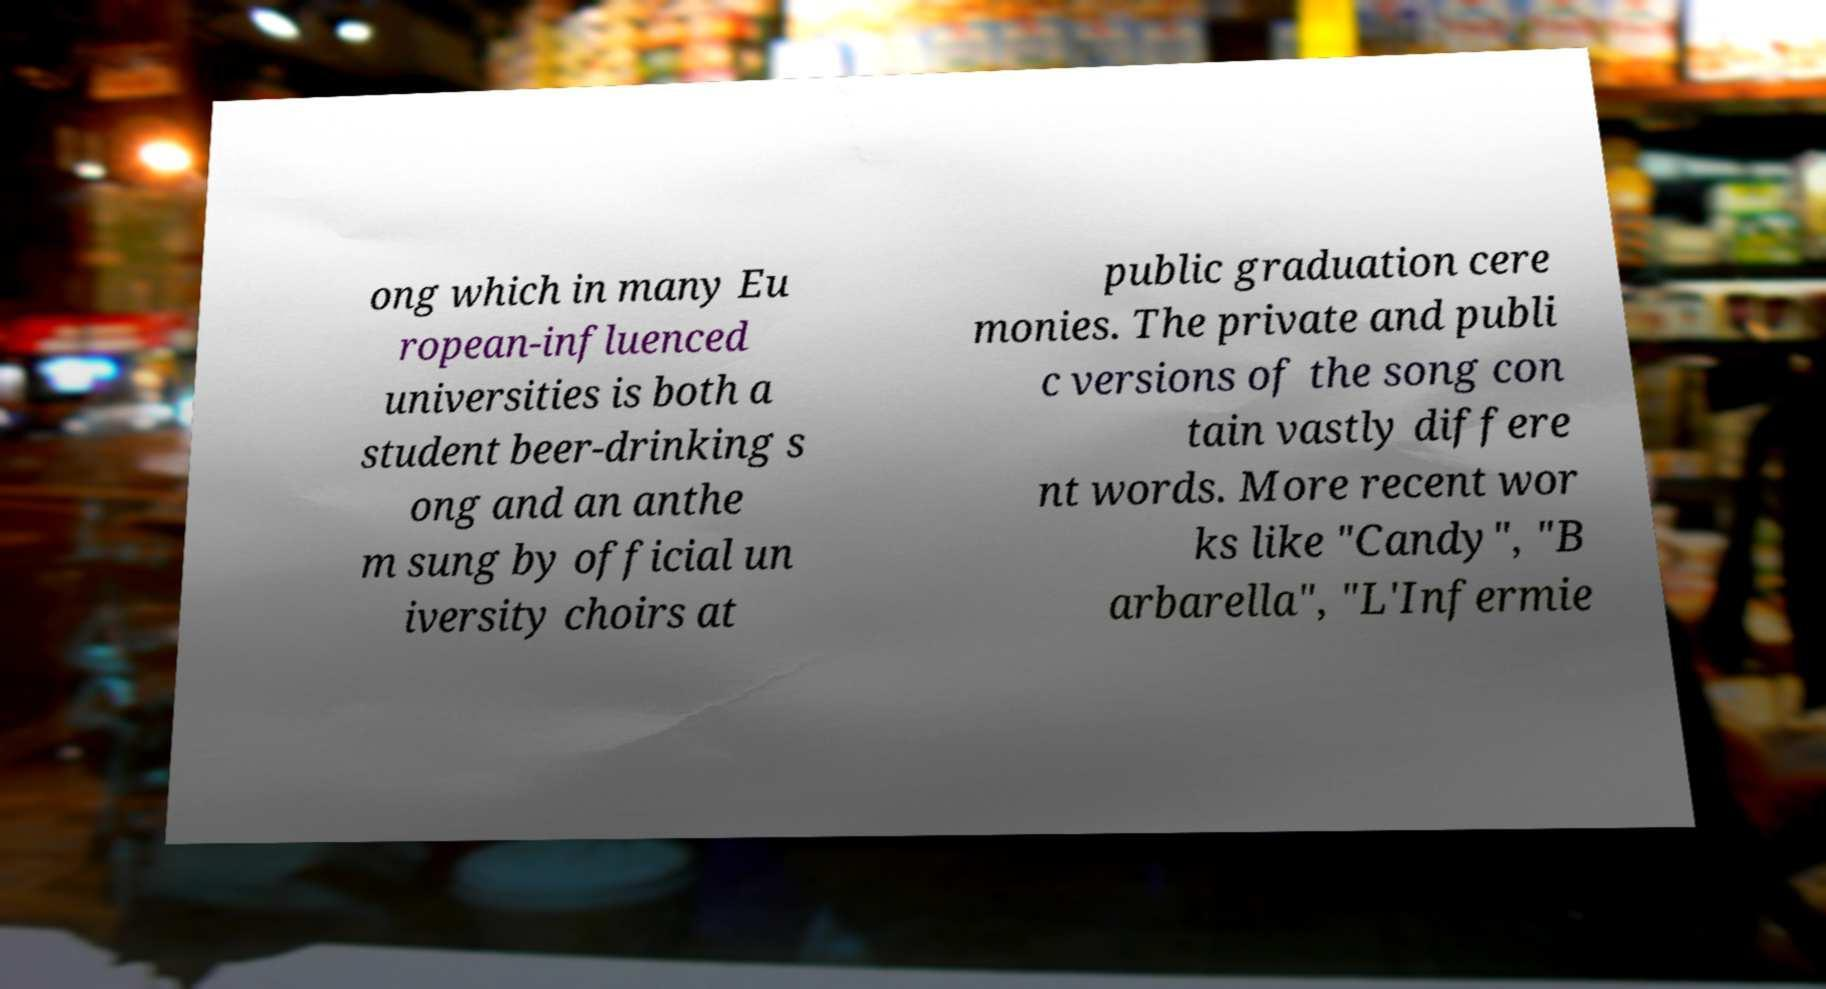Can you accurately transcribe the text from the provided image for me? ong which in many Eu ropean-influenced universities is both a student beer-drinking s ong and an anthe m sung by official un iversity choirs at public graduation cere monies. The private and publi c versions of the song con tain vastly differe nt words. More recent wor ks like "Candy", "B arbarella", "L'Infermie 